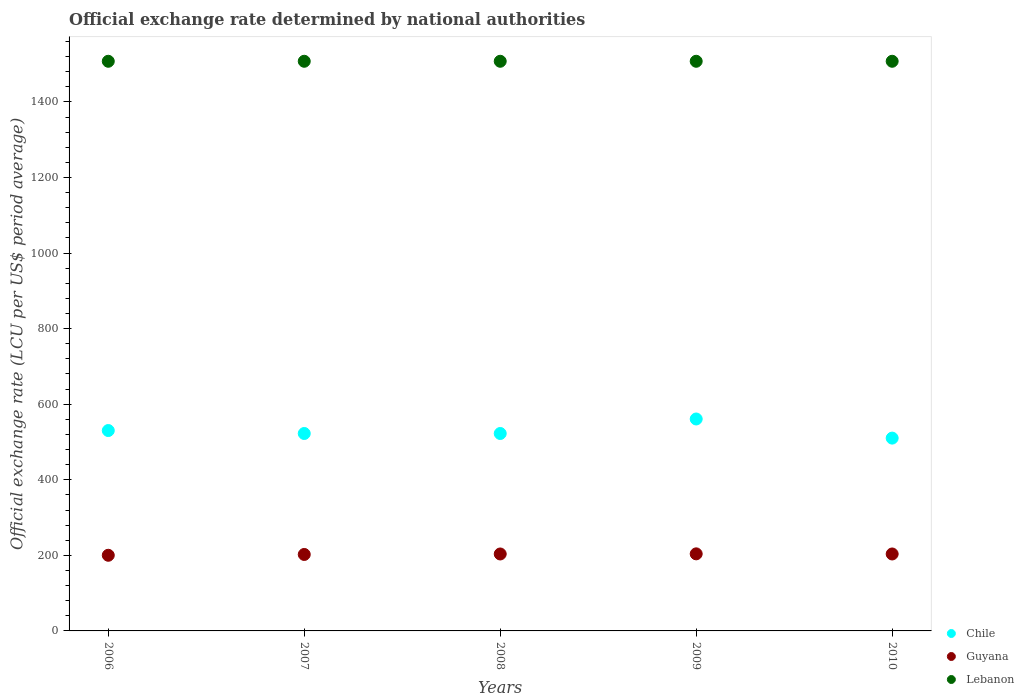How many different coloured dotlines are there?
Your response must be concise. 3. What is the official exchange rate in Guyana in 2008?
Your response must be concise. 203.63. Across all years, what is the maximum official exchange rate in Lebanon?
Provide a short and direct response. 1507.5. Across all years, what is the minimum official exchange rate in Chile?
Your answer should be compact. 510.25. In which year was the official exchange rate in Chile maximum?
Provide a short and direct response. 2009. What is the total official exchange rate in Guyana in the graph?
Your answer should be compact. 1013.75. What is the difference between the official exchange rate in Lebanon in 2007 and the official exchange rate in Chile in 2009?
Give a very brief answer. 946.64. What is the average official exchange rate in Guyana per year?
Your answer should be very brief. 202.75. In the year 2010, what is the difference between the official exchange rate in Chile and official exchange rate in Lebanon?
Ensure brevity in your answer.  -997.25. In how many years, is the official exchange rate in Guyana greater than 1360 LCU?
Make the answer very short. 0. What is the ratio of the official exchange rate in Chile in 2009 to that in 2010?
Offer a very short reply. 1.1. What is the difference between the highest and the second highest official exchange rate in Chile?
Your answer should be very brief. 30.58. What is the difference between the highest and the lowest official exchange rate in Chile?
Keep it short and to the point. 50.61. In how many years, is the official exchange rate in Guyana greater than the average official exchange rate in Guyana taken over all years?
Offer a very short reply. 3. Is the sum of the official exchange rate in Lebanon in 2006 and 2008 greater than the maximum official exchange rate in Chile across all years?
Offer a terse response. Yes. Does the official exchange rate in Lebanon monotonically increase over the years?
Offer a very short reply. No. Is the official exchange rate in Lebanon strictly less than the official exchange rate in Chile over the years?
Offer a very short reply. No. How many dotlines are there?
Your response must be concise. 3. How many years are there in the graph?
Make the answer very short. 5. Are the values on the major ticks of Y-axis written in scientific E-notation?
Provide a succinct answer. No. Does the graph contain any zero values?
Offer a very short reply. No. How many legend labels are there?
Offer a very short reply. 3. How are the legend labels stacked?
Give a very brief answer. Vertical. What is the title of the graph?
Offer a terse response. Official exchange rate determined by national authorities. Does "Slovak Republic" appear as one of the legend labels in the graph?
Your answer should be very brief. No. What is the label or title of the Y-axis?
Provide a succinct answer. Official exchange rate (LCU per US$ period average). What is the Official exchange rate (LCU per US$ period average) in Chile in 2006?
Your answer should be very brief. 530.27. What is the Official exchange rate (LCU per US$ period average) of Guyana in 2006?
Give a very brief answer. 200.19. What is the Official exchange rate (LCU per US$ period average) in Lebanon in 2006?
Your response must be concise. 1507.5. What is the Official exchange rate (LCU per US$ period average) of Chile in 2007?
Provide a succinct answer. 522.46. What is the Official exchange rate (LCU per US$ period average) in Guyana in 2007?
Provide a succinct answer. 202.35. What is the Official exchange rate (LCU per US$ period average) of Lebanon in 2007?
Keep it short and to the point. 1507.5. What is the Official exchange rate (LCU per US$ period average) in Chile in 2008?
Give a very brief answer. 522.46. What is the Official exchange rate (LCU per US$ period average) in Guyana in 2008?
Provide a succinct answer. 203.63. What is the Official exchange rate (LCU per US$ period average) in Lebanon in 2008?
Your response must be concise. 1507.5. What is the Official exchange rate (LCU per US$ period average) in Chile in 2009?
Make the answer very short. 560.86. What is the Official exchange rate (LCU per US$ period average) of Guyana in 2009?
Your answer should be compact. 203.95. What is the Official exchange rate (LCU per US$ period average) in Lebanon in 2009?
Your answer should be compact. 1507.5. What is the Official exchange rate (LCU per US$ period average) in Chile in 2010?
Make the answer very short. 510.25. What is the Official exchange rate (LCU per US$ period average) of Guyana in 2010?
Give a very brief answer. 203.64. What is the Official exchange rate (LCU per US$ period average) in Lebanon in 2010?
Offer a terse response. 1507.5. Across all years, what is the maximum Official exchange rate (LCU per US$ period average) of Chile?
Keep it short and to the point. 560.86. Across all years, what is the maximum Official exchange rate (LCU per US$ period average) in Guyana?
Your answer should be very brief. 203.95. Across all years, what is the maximum Official exchange rate (LCU per US$ period average) in Lebanon?
Your response must be concise. 1507.5. Across all years, what is the minimum Official exchange rate (LCU per US$ period average) of Chile?
Make the answer very short. 510.25. Across all years, what is the minimum Official exchange rate (LCU per US$ period average) in Guyana?
Provide a succinct answer. 200.19. Across all years, what is the minimum Official exchange rate (LCU per US$ period average) of Lebanon?
Offer a terse response. 1507.5. What is the total Official exchange rate (LCU per US$ period average) in Chile in the graph?
Your answer should be compact. 2646.31. What is the total Official exchange rate (LCU per US$ period average) of Guyana in the graph?
Your answer should be very brief. 1013.75. What is the total Official exchange rate (LCU per US$ period average) of Lebanon in the graph?
Provide a succinct answer. 7537.5. What is the difference between the Official exchange rate (LCU per US$ period average) in Chile in 2006 and that in 2007?
Your answer should be compact. 7.81. What is the difference between the Official exchange rate (LCU per US$ period average) in Guyana in 2006 and that in 2007?
Your response must be concise. -2.16. What is the difference between the Official exchange rate (LCU per US$ period average) of Lebanon in 2006 and that in 2007?
Your response must be concise. 0. What is the difference between the Official exchange rate (LCU per US$ period average) in Chile in 2006 and that in 2008?
Your answer should be very brief. 7.81. What is the difference between the Official exchange rate (LCU per US$ period average) of Guyana in 2006 and that in 2008?
Offer a terse response. -3.44. What is the difference between the Official exchange rate (LCU per US$ period average) in Lebanon in 2006 and that in 2008?
Ensure brevity in your answer.  0. What is the difference between the Official exchange rate (LCU per US$ period average) of Chile in 2006 and that in 2009?
Your answer should be compact. -30.58. What is the difference between the Official exchange rate (LCU per US$ period average) in Guyana in 2006 and that in 2009?
Your answer should be very brief. -3.76. What is the difference between the Official exchange rate (LCU per US$ period average) in Chile in 2006 and that in 2010?
Provide a succinct answer. 20.03. What is the difference between the Official exchange rate (LCU per US$ period average) in Guyana in 2006 and that in 2010?
Keep it short and to the point. -3.45. What is the difference between the Official exchange rate (LCU per US$ period average) in Lebanon in 2006 and that in 2010?
Ensure brevity in your answer.  0. What is the difference between the Official exchange rate (LCU per US$ period average) of Chile in 2007 and that in 2008?
Offer a terse response. 0. What is the difference between the Official exchange rate (LCU per US$ period average) of Guyana in 2007 and that in 2008?
Offer a very short reply. -1.29. What is the difference between the Official exchange rate (LCU per US$ period average) of Chile in 2007 and that in 2009?
Provide a short and direct response. -38.4. What is the difference between the Official exchange rate (LCU per US$ period average) in Guyana in 2007 and that in 2009?
Offer a very short reply. -1.6. What is the difference between the Official exchange rate (LCU per US$ period average) of Lebanon in 2007 and that in 2009?
Provide a succinct answer. 0. What is the difference between the Official exchange rate (LCU per US$ period average) of Chile in 2007 and that in 2010?
Provide a short and direct response. 12.21. What is the difference between the Official exchange rate (LCU per US$ period average) in Guyana in 2007 and that in 2010?
Your response must be concise. -1.29. What is the difference between the Official exchange rate (LCU per US$ period average) in Chile in 2008 and that in 2009?
Keep it short and to the point. -38.4. What is the difference between the Official exchange rate (LCU per US$ period average) in Guyana in 2008 and that in 2009?
Provide a short and direct response. -0.32. What is the difference between the Official exchange rate (LCU per US$ period average) in Lebanon in 2008 and that in 2009?
Your answer should be compact. 0. What is the difference between the Official exchange rate (LCU per US$ period average) in Chile in 2008 and that in 2010?
Your answer should be very brief. 12.21. What is the difference between the Official exchange rate (LCU per US$ period average) of Guyana in 2008 and that in 2010?
Keep it short and to the point. -0. What is the difference between the Official exchange rate (LCU per US$ period average) in Lebanon in 2008 and that in 2010?
Give a very brief answer. 0. What is the difference between the Official exchange rate (LCU per US$ period average) of Chile in 2009 and that in 2010?
Your response must be concise. 50.61. What is the difference between the Official exchange rate (LCU per US$ period average) of Guyana in 2009 and that in 2010?
Ensure brevity in your answer.  0.31. What is the difference between the Official exchange rate (LCU per US$ period average) of Chile in 2006 and the Official exchange rate (LCU per US$ period average) of Guyana in 2007?
Offer a very short reply. 327.93. What is the difference between the Official exchange rate (LCU per US$ period average) in Chile in 2006 and the Official exchange rate (LCU per US$ period average) in Lebanon in 2007?
Your answer should be very brief. -977.23. What is the difference between the Official exchange rate (LCU per US$ period average) of Guyana in 2006 and the Official exchange rate (LCU per US$ period average) of Lebanon in 2007?
Offer a terse response. -1307.31. What is the difference between the Official exchange rate (LCU per US$ period average) of Chile in 2006 and the Official exchange rate (LCU per US$ period average) of Guyana in 2008?
Keep it short and to the point. 326.64. What is the difference between the Official exchange rate (LCU per US$ period average) in Chile in 2006 and the Official exchange rate (LCU per US$ period average) in Lebanon in 2008?
Offer a terse response. -977.23. What is the difference between the Official exchange rate (LCU per US$ period average) in Guyana in 2006 and the Official exchange rate (LCU per US$ period average) in Lebanon in 2008?
Provide a succinct answer. -1307.31. What is the difference between the Official exchange rate (LCU per US$ period average) in Chile in 2006 and the Official exchange rate (LCU per US$ period average) in Guyana in 2009?
Ensure brevity in your answer.  326.32. What is the difference between the Official exchange rate (LCU per US$ period average) in Chile in 2006 and the Official exchange rate (LCU per US$ period average) in Lebanon in 2009?
Offer a very short reply. -977.23. What is the difference between the Official exchange rate (LCU per US$ period average) of Guyana in 2006 and the Official exchange rate (LCU per US$ period average) of Lebanon in 2009?
Your response must be concise. -1307.31. What is the difference between the Official exchange rate (LCU per US$ period average) of Chile in 2006 and the Official exchange rate (LCU per US$ period average) of Guyana in 2010?
Make the answer very short. 326.64. What is the difference between the Official exchange rate (LCU per US$ period average) of Chile in 2006 and the Official exchange rate (LCU per US$ period average) of Lebanon in 2010?
Ensure brevity in your answer.  -977.23. What is the difference between the Official exchange rate (LCU per US$ period average) in Guyana in 2006 and the Official exchange rate (LCU per US$ period average) in Lebanon in 2010?
Provide a short and direct response. -1307.31. What is the difference between the Official exchange rate (LCU per US$ period average) in Chile in 2007 and the Official exchange rate (LCU per US$ period average) in Guyana in 2008?
Keep it short and to the point. 318.83. What is the difference between the Official exchange rate (LCU per US$ period average) of Chile in 2007 and the Official exchange rate (LCU per US$ period average) of Lebanon in 2008?
Your answer should be compact. -985.04. What is the difference between the Official exchange rate (LCU per US$ period average) of Guyana in 2007 and the Official exchange rate (LCU per US$ period average) of Lebanon in 2008?
Keep it short and to the point. -1305.15. What is the difference between the Official exchange rate (LCU per US$ period average) in Chile in 2007 and the Official exchange rate (LCU per US$ period average) in Guyana in 2009?
Make the answer very short. 318.51. What is the difference between the Official exchange rate (LCU per US$ period average) of Chile in 2007 and the Official exchange rate (LCU per US$ period average) of Lebanon in 2009?
Ensure brevity in your answer.  -985.04. What is the difference between the Official exchange rate (LCU per US$ period average) of Guyana in 2007 and the Official exchange rate (LCU per US$ period average) of Lebanon in 2009?
Give a very brief answer. -1305.15. What is the difference between the Official exchange rate (LCU per US$ period average) of Chile in 2007 and the Official exchange rate (LCU per US$ period average) of Guyana in 2010?
Your answer should be very brief. 318.83. What is the difference between the Official exchange rate (LCU per US$ period average) in Chile in 2007 and the Official exchange rate (LCU per US$ period average) in Lebanon in 2010?
Offer a terse response. -985.04. What is the difference between the Official exchange rate (LCU per US$ period average) in Guyana in 2007 and the Official exchange rate (LCU per US$ period average) in Lebanon in 2010?
Your answer should be very brief. -1305.15. What is the difference between the Official exchange rate (LCU per US$ period average) of Chile in 2008 and the Official exchange rate (LCU per US$ period average) of Guyana in 2009?
Your response must be concise. 318.51. What is the difference between the Official exchange rate (LCU per US$ period average) in Chile in 2008 and the Official exchange rate (LCU per US$ period average) in Lebanon in 2009?
Keep it short and to the point. -985.04. What is the difference between the Official exchange rate (LCU per US$ period average) in Guyana in 2008 and the Official exchange rate (LCU per US$ period average) in Lebanon in 2009?
Provide a short and direct response. -1303.87. What is the difference between the Official exchange rate (LCU per US$ period average) of Chile in 2008 and the Official exchange rate (LCU per US$ period average) of Guyana in 2010?
Your response must be concise. 318.83. What is the difference between the Official exchange rate (LCU per US$ period average) in Chile in 2008 and the Official exchange rate (LCU per US$ period average) in Lebanon in 2010?
Keep it short and to the point. -985.04. What is the difference between the Official exchange rate (LCU per US$ period average) in Guyana in 2008 and the Official exchange rate (LCU per US$ period average) in Lebanon in 2010?
Your answer should be compact. -1303.87. What is the difference between the Official exchange rate (LCU per US$ period average) in Chile in 2009 and the Official exchange rate (LCU per US$ period average) in Guyana in 2010?
Your answer should be very brief. 357.22. What is the difference between the Official exchange rate (LCU per US$ period average) of Chile in 2009 and the Official exchange rate (LCU per US$ period average) of Lebanon in 2010?
Make the answer very short. -946.64. What is the difference between the Official exchange rate (LCU per US$ period average) in Guyana in 2009 and the Official exchange rate (LCU per US$ period average) in Lebanon in 2010?
Provide a short and direct response. -1303.55. What is the average Official exchange rate (LCU per US$ period average) in Chile per year?
Ensure brevity in your answer.  529.26. What is the average Official exchange rate (LCU per US$ period average) in Guyana per year?
Provide a succinct answer. 202.75. What is the average Official exchange rate (LCU per US$ period average) of Lebanon per year?
Your response must be concise. 1507.5. In the year 2006, what is the difference between the Official exchange rate (LCU per US$ period average) in Chile and Official exchange rate (LCU per US$ period average) in Guyana?
Ensure brevity in your answer.  330.09. In the year 2006, what is the difference between the Official exchange rate (LCU per US$ period average) of Chile and Official exchange rate (LCU per US$ period average) of Lebanon?
Make the answer very short. -977.23. In the year 2006, what is the difference between the Official exchange rate (LCU per US$ period average) in Guyana and Official exchange rate (LCU per US$ period average) in Lebanon?
Make the answer very short. -1307.31. In the year 2007, what is the difference between the Official exchange rate (LCU per US$ period average) of Chile and Official exchange rate (LCU per US$ period average) of Guyana?
Your answer should be compact. 320.12. In the year 2007, what is the difference between the Official exchange rate (LCU per US$ period average) of Chile and Official exchange rate (LCU per US$ period average) of Lebanon?
Offer a terse response. -985.04. In the year 2007, what is the difference between the Official exchange rate (LCU per US$ period average) in Guyana and Official exchange rate (LCU per US$ period average) in Lebanon?
Keep it short and to the point. -1305.15. In the year 2008, what is the difference between the Official exchange rate (LCU per US$ period average) in Chile and Official exchange rate (LCU per US$ period average) in Guyana?
Give a very brief answer. 318.83. In the year 2008, what is the difference between the Official exchange rate (LCU per US$ period average) of Chile and Official exchange rate (LCU per US$ period average) of Lebanon?
Make the answer very short. -985.04. In the year 2008, what is the difference between the Official exchange rate (LCU per US$ period average) of Guyana and Official exchange rate (LCU per US$ period average) of Lebanon?
Keep it short and to the point. -1303.87. In the year 2009, what is the difference between the Official exchange rate (LCU per US$ period average) of Chile and Official exchange rate (LCU per US$ period average) of Guyana?
Offer a terse response. 356.91. In the year 2009, what is the difference between the Official exchange rate (LCU per US$ period average) of Chile and Official exchange rate (LCU per US$ period average) of Lebanon?
Ensure brevity in your answer.  -946.64. In the year 2009, what is the difference between the Official exchange rate (LCU per US$ period average) of Guyana and Official exchange rate (LCU per US$ period average) of Lebanon?
Ensure brevity in your answer.  -1303.55. In the year 2010, what is the difference between the Official exchange rate (LCU per US$ period average) of Chile and Official exchange rate (LCU per US$ period average) of Guyana?
Ensure brevity in your answer.  306.61. In the year 2010, what is the difference between the Official exchange rate (LCU per US$ period average) in Chile and Official exchange rate (LCU per US$ period average) in Lebanon?
Keep it short and to the point. -997.25. In the year 2010, what is the difference between the Official exchange rate (LCU per US$ period average) of Guyana and Official exchange rate (LCU per US$ period average) of Lebanon?
Make the answer very short. -1303.86. What is the ratio of the Official exchange rate (LCU per US$ period average) in Chile in 2006 to that in 2007?
Your response must be concise. 1.01. What is the ratio of the Official exchange rate (LCU per US$ period average) in Guyana in 2006 to that in 2007?
Your response must be concise. 0.99. What is the ratio of the Official exchange rate (LCU per US$ period average) of Chile in 2006 to that in 2008?
Your answer should be compact. 1.01. What is the ratio of the Official exchange rate (LCU per US$ period average) in Guyana in 2006 to that in 2008?
Make the answer very short. 0.98. What is the ratio of the Official exchange rate (LCU per US$ period average) in Chile in 2006 to that in 2009?
Make the answer very short. 0.95. What is the ratio of the Official exchange rate (LCU per US$ period average) in Guyana in 2006 to that in 2009?
Your answer should be very brief. 0.98. What is the ratio of the Official exchange rate (LCU per US$ period average) in Lebanon in 2006 to that in 2009?
Offer a terse response. 1. What is the ratio of the Official exchange rate (LCU per US$ period average) in Chile in 2006 to that in 2010?
Your answer should be compact. 1.04. What is the ratio of the Official exchange rate (LCU per US$ period average) of Guyana in 2006 to that in 2010?
Provide a succinct answer. 0.98. What is the ratio of the Official exchange rate (LCU per US$ period average) of Chile in 2007 to that in 2008?
Ensure brevity in your answer.  1. What is the ratio of the Official exchange rate (LCU per US$ period average) in Lebanon in 2007 to that in 2008?
Provide a short and direct response. 1. What is the ratio of the Official exchange rate (LCU per US$ period average) of Chile in 2007 to that in 2009?
Your answer should be very brief. 0.93. What is the ratio of the Official exchange rate (LCU per US$ period average) of Lebanon in 2007 to that in 2009?
Your response must be concise. 1. What is the ratio of the Official exchange rate (LCU per US$ period average) in Chile in 2007 to that in 2010?
Your response must be concise. 1.02. What is the ratio of the Official exchange rate (LCU per US$ period average) of Guyana in 2007 to that in 2010?
Provide a succinct answer. 0.99. What is the ratio of the Official exchange rate (LCU per US$ period average) of Lebanon in 2007 to that in 2010?
Provide a succinct answer. 1. What is the ratio of the Official exchange rate (LCU per US$ period average) of Chile in 2008 to that in 2009?
Keep it short and to the point. 0.93. What is the ratio of the Official exchange rate (LCU per US$ period average) in Guyana in 2008 to that in 2009?
Offer a very short reply. 1. What is the ratio of the Official exchange rate (LCU per US$ period average) of Chile in 2008 to that in 2010?
Ensure brevity in your answer.  1.02. What is the ratio of the Official exchange rate (LCU per US$ period average) of Guyana in 2008 to that in 2010?
Provide a short and direct response. 1. What is the ratio of the Official exchange rate (LCU per US$ period average) of Chile in 2009 to that in 2010?
Offer a terse response. 1.1. What is the ratio of the Official exchange rate (LCU per US$ period average) of Guyana in 2009 to that in 2010?
Your answer should be very brief. 1. What is the difference between the highest and the second highest Official exchange rate (LCU per US$ period average) in Chile?
Your answer should be very brief. 30.58. What is the difference between the highest and the second highest Official exchange rate (LCU per US$ period average) in Guyana?
Give a very brief answer. 0.31. What is the difference between the highest and the second highest Official exchange rate (LCU per US$ period average) of Lebanon?
Your answer should be compact. 0. What is the difference between the highest and the lowest Official exchange rate (LCU per US$ period average) of Chile?
Your answer should be compact. 50.61. What is the difference between the highest and the lowest Official exchange rate (LCU per US$ period average) in Guyana?
Offer a very short reply. 3.76. What is the difference between the highest and the lowest Official exchange rate (LCU per US$ period average) in Lebanon?
Give a very brief answer. 0. 